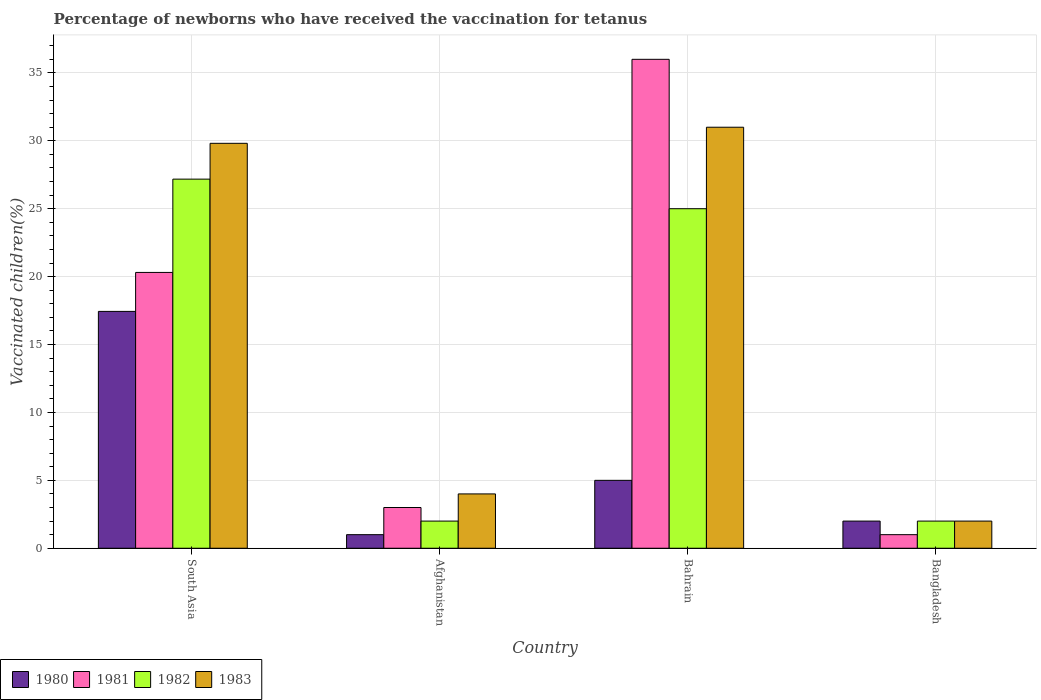How many different coloured bars are there?
Give a very brief answer. 4. Are the number of bars per tick equal to the number of legend labels?
Your answer should be very brief. Yes. How many bars are there on the 4th tick from the left?
Offer a terse response. 4. How many bars are there on the 3rd tick from the right?
Give a very brief answer. 4. What is the percentage of vaccinated children in 1983 in Bangladesh?
Offer a terse response. 2. Across all countries, what is the maximum percentage of vaccinated children in 1980?
Give a very brief answer. 17.44. In which country was the percentage of vaccinated children in 1981 maximum?
Your answer should be compact. Bahrain. In which country was the percentage of vaccinated children in 1983 minimum?
Your answer should be compact. Bangladesh. What is the total percentage of vaccinated children in 1982 in the graph?
Your response must be concise. 56.18. What is the difference between the percentage of vaccinated children in 1980 in Afghanistan and that in Bangladesh?
Offer a very short reply. -1. What is the average percentage of vaccinated children in 1981 per country?
Your answer should be compact. 15.08. What is the difference between the percentage of vaccinated children of/in 1983 and percentage of vaccinated children of/in 1980 in Bahrain?
Offer a very short reply. 26. In how many countries, is the percentage of vaccinated children in 1980 greater than 4 %?
Offer a terse response. 2. What is the difference between the highest and the second highest percentage of vaccinated children in 1980?
Your answer should be very brief. 15.44. What is the difference between the highest and the lowest percentage of vaccinated children in 1980?
Offer a terse response. 16.44. In how many countries, is the percentage of vaccinated children in 1983 greater than the average percentage of vaccinated children in 1983 taken over all countries?
Offer a very short reply. 2. Is the sum of the percentage of vaccinated children in 1981 in Bahrain and Bangladesh greater than the maximum percentage of vaccinated children in 1980 across all countries?
Offer a terse response. Yes. Is it the case that in every country, the sum of the percentage of vaccinated children in 1981 and percentage of vaccinated children in 1980 is greater than the sum of percentage of vaccinated children in 1982 and percentage of vaccinated children in 1983?
Your answer should be compact. No. What does the 1st bar from the left in Afghanistan represents?
Offer a very short reply. 1980. What does the 3rd bar from the right in Bangladesh represents?
Give a very brief answer. 1981. How many bars are there?
Offer a terse response. 16. Are all the bars in the graph horizontal?
Your answer should be very brief. No. Does the graph contain any zero values?
Give a very brief answer. No. Where does the legend appear in the graph?
Your answer should be compact. Bottom left. How many legend labels are there?
Your response must be concise. 4. How are the legend labels stacked?
Your answer should be very brief. Horizontal. What is the title of the graph?
Your response must be concise. Percentage of newborns who have received the vaccination for tetanus. Does "2011" appear as one of the legend labels in the graph?
Provide a short and direct response. No. What is the label or title of the X-axis?
Offer a very short reply. Country. What is the label or title of the Y-axis?
Offer a very short reply. Vaccinated children(%). What is the Vaccinated children(%) in 1980 in South Asia?
Ensure brevity in your answer.  17.44. What is the Vaccinated children(%) in 1981 in South Asia?
Your answer should be very brief. 20.31. What is the Vaccinated children(%) in 1982 in South Asia?
Make the answer very short. 27.18. What is the Vaccinated children(%) in 1983 in South Asia?
Keep it short and to the point. 29.81. What is the Vaccinated children(%) of 1980 in Afghanistan?
Keep it short and to the point. 1. What is the Vaccinated children(%) in 1983 in Afghanistan?
Your answer should be compact. 4. What is the Vaccinated children(%) in 1980 in Bahrain?
Ensure brevity in your answer.  5. What is the Vaccinated children(%) in 1981 in Bahrain?
Offer a terse response. 36. What is the Vaccinated children(%) in 1983 in Bahrain?
Give a very brief answer. 31. What is the Vaccinated children(%) of 1980 in Bangladesh?
Make the answer very short. 2. What is the Vaccinated children(%) of 1981 in Bangladesh?
Provide a succinct answer. 1. What is the Vaccinated children(%) in 1982 in Bangladesh?
Offer a terse response. 2. Across all countries, what is the maximum Vaccinated children(%) in 1980?
Make the answer very short. 17.44. Across all countries, what is the maximum Vaccinated children(%) in 1982?
Provide a succinct answer. 27.18. Across all countries, what is the minimum Vaccinated children(%) in 1981?
Your answer should be compact. 1. Across all countries, what is the minimum Vaccinated children(%) in 1983?
Provide a short and direct response. 2. What is the total Vaccinated children(%) in 1980 in the graph?
Ensure brevity in your answer.  25.44. What is the total Vaccinated children(%) in 1981 in the graph?
Your answer should be very brief. 60.31. What is the total Vaccinated children(%) of 1982 in the graph?
Make the answer very short. 56.18. What is the total Vaccinated children(%) of 1983 in the graph?
Provide a succinct answer. 66.81. What is the difference between the Vaccinated children(%) in 1980 in South Asia and that in Afghanistan?
Make the answer very short. 16.44. What is the difference between the Vaccinated children(%) in 1981 in South Asia and that in Afghanistan?
Offer a terse response. 17.31. What is the difference between the Vaccinated children(%) of 1982 in South Asia and that in Afghanistan?
Provide a short and direct response. 25.18. What is the difference between the Vaccinated children(%) of 1983 in South Asia and that in Afghanistan?
Ensure brevity in your answer.  25.81. What is the difference between the Vaccinated children(%) of 1980 in South Asia and that in Bahrain?
Your answer should be very brief. 12.44. What is the difference between the Vaccinated children(%) of 1981 in South Asia and that in Bahrain?
Ensure brevity in your answer.  -15.69. What is the difference between the Vaccinated children(%) of 1982 in South Asia and that in Bahrain?
Give a very brief answer. 2.18. What is the difference between the Vaccinated children(%) of 1983 in South Asia and that in Bahrain?
Your answer should be compact. -1.19. What is the difference between the Vaccinated children(%) in 1980 in South Asia and that in Bangladesh?
Ensure brevity in your answer.  15.44. What is the difference between the Vaccinated children(%) of 1981 in South Asia and that in Bangladesh?
Make the answer very short. 19.31. What is the difference between the Vaccinated children(%) in 1982 in South Asia and that in Bangladesh?
Your response must be concise. 25.18. What is the difference between the Vaccinated children(%) of 1983 in South Asia and that in Bangladesh?
Make the answer very short. 27.81. What is the difference between the Vaccinated children(%) in 1981 in Afghanistan and that in Bahrain?
Provide a short and direct response. -33. What is the difference between the Vaccinated children(%) of 1982 in Afghanistan and that in Bahrain?
Offer a terse response. -23. What is the difference between the Vaccinated children(%) in 1983 in Afghanistan and that in Bahrain?
Keep it short and to the point. -27. What is the difference between the Vaccinated children(%) in 1982 in Afghanistan and that in Bangladesh?
Your answer should be very brief. 0. What is the difference between the Vaccinated children(%) of 1983 in Afghanistan and that in Bangladesh?
Provide a succinct answer. 2. What is the difference between the Vaccinated children(%) in 1980 in Bahrain and that in Bangladesh?
Provide a short and direct response. 3. What is the difference between the Vaccinated children(%) of 1981 in Bahrain and that in Bangladesh?
Your answer should be very brief. 35. What is the difference between the Vaccinated children(%) of 1982 in Bahrain and that in Bangladesh?
Make the answer very short. 23. What is the difference between the Vaccinated children(%) in 1980 in South Asia and the Vaccinated children(%) in 1981 in Afghanistan?
Provide a short and direct response. 14.44. What is the difference between the Vaccinated children(%) in 1980 in South Asia and the Vaccinated children(%) in 1982 in Afghanistan?
Provide a succinct answer. 15.44. What is the difference between the Vaccinated children(%) of 1980 in South Asia and the Vaccinated children(%) of 1983 in Afghanistan?
Offer a terse response. 13.44. What is the difference between the Vaccinated children(%) of 1981 in South Asia and the Vaccinated children(%) of 1982 in Afghanistan?
Offer a terse response. 18.31. What is the difference between the Vaccinated children(%) in 1981 in South Asia and the Vaccinated children(%) in 1983 in Afghanistan?
Your answer should be compact. 16.31. What is the difference between the Vaccinated children(%) in 1982 in South Asia and the Vaccinated children(%) in 1983 in Afghanistan?
Offer a very short reply. 23.18. What is the difference between the Vaccinated children(%) of 1980 in South Asia and the Vaccinated children(%) of 1981 in Bahrain?
Offer a terse response. -18.56. What is the difference between the Vaccinated children(%) of 1980 in South Asia and the Vaccinated children(%) of 1982 in Bahrain?
Ensure brevity in your answer.  -7.56. What is the difference between the Vaccinated children(%) of 1980 in South Asia and the Vaccinated children(%) of 1983 in Bahrain?
Keep it short and to the point. -13.56. What is the difference between the Vaccinated children(%) in 1981 in South Asia and the Vaccinated children(%) in 1982 in Bahrain?
Provide a succinct answer. -4.69. What is the difference between the Vaccinated children(%) in 1981 in South Asia and the Vaccinated children(%) in 1983 in Bahrain?
Ensure brevity in your answer.  -10.69. What is the difference between the Vaccinated children(%) in 1982 in South Asia and the Vaccinated children(%) in 1983 in Bahrain?
Ensure brevity in your answer.  -3.82. What is the difference between the Vaccinated children(%) in 1980 in South Asia and the Vaccinated children(%) in 1981 in Bangladesh?
Offer a terse response. 16.44. What is the difference between the Vaccinated children(%) of 1980 in South Asia and the Vaccinated children(%) of 1982 in Bangladesh?
Give a very brief answer. 15.44. What is the difference between the Vaccinated children(%) of 1980 in South Asia and the Vaccinated children(%) of 1983 in Bangladesh?
Make the answer very short. 15.44. What is the difference between the Vaccinated children(%) of 1981 in South Asia and the Vaccinated children(%) of 1982 in Bangladesh?
Offer a terse response. 18.31. What is the difference between the Vaccinated children(%) in 1981 in South Asia and the Vaccinated children(%) in 1983 in Bangladesh?
Provide a succinct answer. 18.31. What is the difference between the Vaccinated children(%) of 1982 in South Asia and the Vaccinated children(%) of 1983 in Bangladesh?
Your answer should be compact. 25.18. What is the difference between the Vaccinated children(%) in 1980 in Afghanistan and the Vaccinated children(%) in 1981 in Bahrain?
Give a very brief answer. -35. What is the difference between the Vaccinated children(%) in 1982 in Afghanistan and the Vaccinated children(%) in 1983 in Bahrain?
Give a very brief answer. -29. What is the difference between the Vaccinated children(%) in 1981 in Afghanistan and the Vaccinated children(%) in 1982 in Bangladesh?
Offer a terse response. 1. What is the difference between the Vaccinated children(%) in 1982 in Afghanistan and the Vaccinated children(%) in 1983 in Bangladesh?
Give a very brief answer. 0. What is the difference between the Vaccinated children(%) in 1981 in Bahrain and the Vaccinated children(%) in 1982 in Bangladesh?
Ensure brevity in your answer.  34. What is the difference between the Vaccinated children(%) of 1981 in Bahrain and the Vaccinated children(%) of 1983 in Bangladesh?
Your answer should be compact. 34. What is the average Vaccinated children(%) in 1980 per country?
Provide a succinct answer. 6.36. What is the average Vaccinated children(%) in 1981 per country?
Your response must be concise. 15.08. What is the average Vaccinated children(%) of 1982 per country?
Offer a terse response. 14.04. What is the average Vaccinated children(%) of 1983 per country?
Make the answer very short. 16.7. What is the difference between the Vaccinated children(%) in 1980 and Vaccinated children(%) in 1981 in South Asia?
Keep it short and to the point. -2.87. What is the difference between the Vaccinated children(%) in 1980 and Vaccinated children(%) in 1982 in South Asia?
Make the answer very short. -9.74. What is the difference between the Vaccinated children(%) in 1980 and Vaccinated children(%) in 1983 in South Asia?
Give a very brief answer. -12.37. What is the difference between the Vaccinated children(%) in 1981 and Vaccinated children(%) in 1982 in South Asia?
Ensure brevity in your answer.  -6.87. What is the difference between the Vaccinated children(%) in 1981 and Vaccinated children(%) in 1983 in South Asia?
Make the answer very short. -9.51. What is the difference between the Vaccinated children(%) in 1982 and Vaccinated children(%) in 1983 in South Asia?
Your response must be concise. -2.64. What is the difference between the Vaccinated children(%) in 1980 and Vaccinated children(%) in 1982 in Afghanistan?
Your response must be concise. -1. What is the difference between the Vaccinated children(%) in 1982 and Vaccinated children(%) in 1983 in Afghanistan?
Your response must be concise. -2. What is the difference between the Vaccinated children(%) in 1980 and Vaccinated children(%) in 1981 in Bahrain?
Provide a short and direct response. -31. What is the difference between the Vaccinated children(%) of 1980 and Vaccinated children(%) of 1982 in Bahrain?
Make the answer very short. -20. What is the difference between the Vaccinated children(%) of 1980 and Vaccinated children(%) of 1983 in Bahrain?
Offer a terse response. -26. What is the difference between the Vaccinated children(%) in 1980 and Vaccinated children(%) in 1983 in Bangladesh?
Give a very brief answer. 0. What is the difference between the Vaccinated children(%) of 1982 and Vaccinated children(%) of 1983 in Bangladesh?
Your answer should be very brief. 0. What is the ratio of the Vaccinated children(%) of 1980 in South Asia to that in Afghanistan?
Offer a terse response. 17.44. What is the ratio of the Vaccinated children(%) in 1981 in South Asia to that in Afghanistan?
Your answer should be very brief. 6.77. What is the ratio of the Vaccinated children(%) in 1982 in South Asia to that in Afghanistan?
Make the answer very short. 13.59. What is the ratio of the Vaccinated children(%) in 1983 in South Asia to that in Afghanistan?
Ensure brevity in your answer.  7.45. What is the ratio of the Vaccinated children(%) in 1980 in South Asia to that in Bahrain?
Ensure brevity in your answer.  3.49. What is the ratio of the Vaccinated children(%) of 1981 in South Asia to that in Bahrain?
Your response must be concise. 0.56. What is the ratio of the Vaccinated children(%) of 1982 in South Asia to that in Bahrain?
Your answer should be very brief. 1.09. What is the ratio of the Vaccinated children(%) of 1983 in South Asia to that in Bahrain?
Provide a short and direct response. 0.96. What is the ratio of the Vaccinated children(%) in 1980 in South Asia to that in Bangladesh?
Provide a succinct answer. 8.72. What is the ratio of the Vaccinated children(%) of 1981 in South Asia to that in Bangladesh?
Your response must be concise. 20.31. What is the ratio of the Vaccinated children(%) of 1982 in South Asia to that in Bangladesh?
Make the answer very short. 13.59. What is the ratio of the Vaccinated children(%) in 1983 in South Asia to that in Bangladesh?
Your response must be concise. 14.91. What is the ratio of the Vaccinated children(%) in 1981 in Afghanistan to that in Bahrain?
Give a very brief answer. 0.08. What is the ratio of the Vaccinated children(%) in 1982 in Afghanistan to that in Bahrain?
Offer a terse response. 0.08. What is the ratio of the Vaccinated children(%) in 1983 in Afghanistan to that in Bahrain?
Provide a short and direct response. 0.13. What is the ratio of the Vaccinated children(%) of 1981 in Afghanistan to that in Bangladesh?
Your answer should be very brief. 3. What is the ratio of the Vaccinated children(%) in 1981 in Bahrain to that in Bangladesh?
Make the answer very short. 36. What is the ratio of the Vaccinated children(%) in 1983 in Bahrain to that in Bangladesh?
Provide a succinct answer. 15.5. What is the difference between the highest and the second highest Vaccinated children(%) of 1980?
Your response must be concise. 12.44. What is the difference between the highest and the second highest Vaccinated children(%) of 1981?
Your answer should be very brief. 15.69. What is the difference between the highest and the second highest Vaccinated children(%) in 1982?
Give a very brief answer. 2.18. What is the difference between the highest and the second highest Vaccinated children(%) of 1983?
Offer a very short reply. 1.19. What is the difference between the highest and the lowest Vaccinated children(%) in 1980?
Offer a very short reply. 16.44. What is the difference between the highest and the lowest Vaccinated children(%) of 1981?
Your answer should be very brief. 35. What is the difference between the highest and the lowest Vaccinated children(%) of 1982?
Your answer should be very brief. 25.18. 